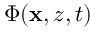Convert formula to latex. <formula><loc_0><loc_0><loc_500><loc_500>\Phi ( x , z , t )</formula> 